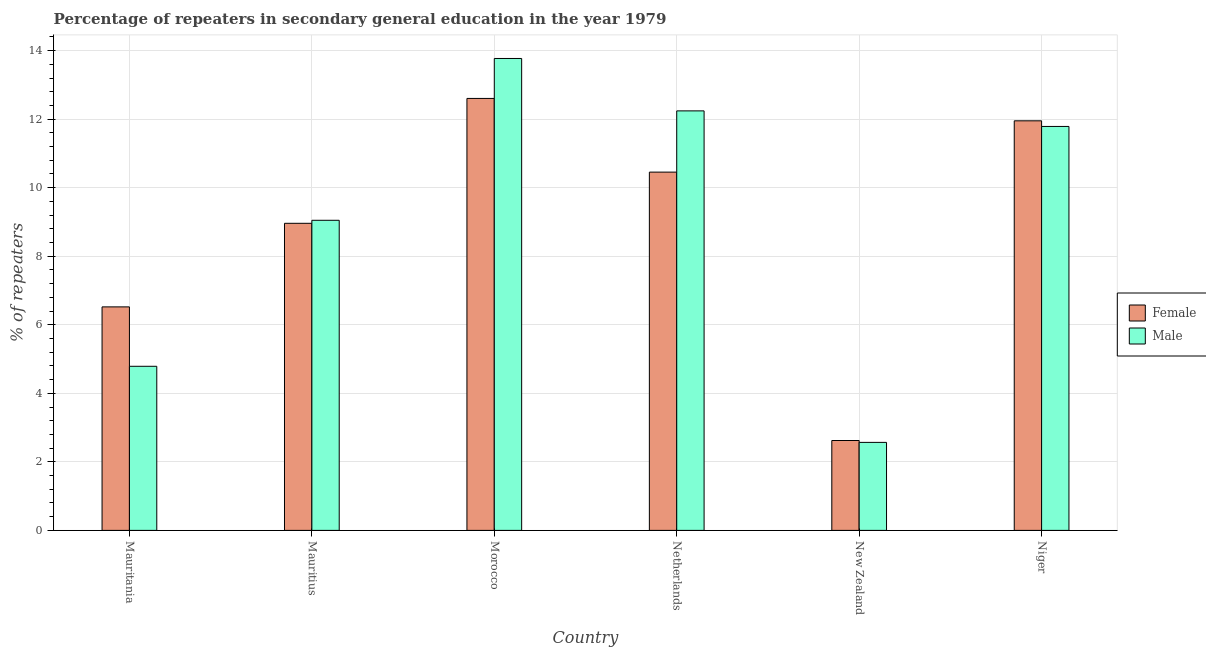How many different coloured bars are there?
Make the answer very short. 2. How many groups of bars are there?
Make the answer very short. 6. Are the number of bars on each tick of the X-axis equal?
Your response must be concise. Yes. How many bars are there on the 3rd tick from the left?
Your answer should be very brief. 2. What is the label of the 2nd group of bars from the left?
Provide a short and direct response. Mauritius. In how many cases, is the number of bars for a given country not equal to the number of legend labels?
Offer a very short reply. 0. What is the percentage of female repeaters in Mauritania?
Provide a succinct answer. 6.52. Across all countries, what is the maximum percentage of female repeaters?
Offer a very short reply. 12.6. Across all countries, what is the minimum percentage of male repeaters?
Offer a terse response. 2.57. In which country was the percentage of female repeaters maximum?
Give a very brief answer. Morocco. In which country was the percentage of female repeaters minimum?
Make the answer very short. New Zealand. What is the total percentage of male repeaters in the graph?
Your answer should be very brief. 54.2. What is the difference between the percentage of male repeaters in Mauritius and that in New Zealand?
Provide a short and direct response. 6.48. What is the difference between the percentage of female repeaters in Niger and the percentage of male repeaters in Mauritius?
Give a very brief answer. 2.9. What is the average percentage of female repeaters per country?
Give a very brief answer. 8.85. What is the difference between the percentage of male repeaters and percentage of female repeaters in Mauritius?
Your answer should be very brief. 0.09. In how many countries, is the percentage of male repeaters greater than 10 %?
Offer a very short reply. 3. What is the ratio of the percentage of female repeaters in Mauritania to that in Netherlands?
Offer a very short reply. 0.62. Is the difference between the percentage of female repeaters in Netherlands and New Zealand greater than the difference between the percentage of male repeaters in Netherlands and New Zealand?
Your answer should be very brief. No. What is the difference between the highest and the second highest percentage of male repeaters?
Your answer should be very brief. 1.53. What is the difference between the highest and the lowest percentage of male repeaters?
Ensure brevity in your answer.  11.2. In how many countries, is the percentage of male repeaters greater than the average percentage of male repeaters taken over all countries?
Give a very brief answer. 4. Is the sum of the percentage of female repeaters in Netherlands and Niger greater than the maximum percentage of male repeaters across all countries?
Your response must be concise. Yes. How many countries are there in the graph?
Provide a succinct answer. 6. Does the graph contain any zero values?
Offer a terse response. No. Does the graph contain grids?
Make the answer very short. Yes. Where does the legend appear in the graph?
Provide a short and direct response. Center right. What is the title of the graph?
Provide a short and direct response. Percentage of repeaters in secondary general education in the year 1979. What is the label or title of the X-axis?
Keep it short and to the point. Country. What is the label or title of the Y-axis?
Your response must be concise. % of repeaters. What is the % of repeaters of Female in Mauritania?
Give a very brief answer. 6.52. What is the % of repeaters of Male in Mauritania?
Make the answer very short. 4.79. What is the % of repeaters in Female in Mauritius?
Provide a short and direct response. 8.96. What is the % of repeaters of Male in Mauritius?
Give a very brief answer. 9.05. What is the % of repeaters in Female in Morocco?
Your response must be concise. 12.6. What is the % of repeaters of Male in Morocco?
Provide a succinct answer. 13.77. What is the % of repeaters in Female in Netherlands?
Keep it short and to the point. 10.45. What is the % of repeaters in Male in Netherlands?
Ensure brevity in your answer.  12.24. What is the % of repeaters of Female in New Zealand?
Offer a terse response. 2.62. What is the % of repeaters in Male in New Zealand?
Your answer should be compact. 2.57. What is the % of repeaters in Female in Niger?
Offer a very short reply. 11.95. What is the % of repeaters in Male in Niger?
Provide a succinct answer. 11.79. Across all countries, what is the maximum % of repeaters in Female?
Provide a short and direct response. 12.6. Across all countries, what is the maximum % of repeaters in Male?
Your answer should be very brief. 13.77. Across all countries, what is the minimum % of repeaters in Female?
Give a very brief answer. 2.62. Across all countries, what is the minimum % of repeaters of Male?
Your answer should be compact. 2.57. What is the total % of repeaters of Female in the graph?
Keep it short and to the point. 53.11. What is the total % of repeaters in Male in the graph?
Your answer should be compact. 54.2. What is the difference between the % of repeaters in Female in Mauritania and that in Mauritius?
Your response must be concise. -2.44. What is the difference between the % of repeaters of Male in Mauritania and that in Mauritius?
Provide a short and direct response. -4.26. What is the difference between the % of repeaters in Female in Mauritania and that in Morocco?
Ensure brevity in your answer.  -6.08. What is the difference between the % of repeaters of Male in Mauritania and that in Morocco?
Keep it short and to the point. -8.98. What is the difference between the % of repeaters of Female in Mauritania and that in Netherlands?
Your response must be concise. -3.93. What is the difference between the % of repeaters of Male in Mauritania and that in Netherlands?
Ensure brevity in your answer.  -7.45. What is the difference between the % of repeaters of Female in Mauritania and that in New Zealand?
Offer a very short reply. 3.9. What is the difference between the % of repeaters of Male in Mauritania and that in New Zealand?
Give a very brief answer. 2.22. What is the difference between the % of repeaters in Female in Mauritania and that in Niger?
Give a very brief answer. -5.43. What is the difference between the % of repeaters in Male in Mauritania and that in Niger?
Provide a short and direct response. -7. What is the difference between the % of repeaters of Female in Mauritius and that in Morocco?
Offer a very short reply. -3.64. What is the difference between the % of repeaters of Male in Mauritius and that in Morocco?
Your answer should be compact. -4.72. What is the difference between the % of repeaters of Female in Mauritius and that in Netherlands?
Provide a short and direct response. -1.49. What is the difference between the % of repeaters of Male in Mauritius and that in Netherlands?
Provide a succinct answer. -3.19. What is the difference between the % of repeaters of Female in Mauritius and that in New Zealand?
Offer a terse response. 6.34. What is the difference between the % of repeaters in Male in Mauritius and that in New Zealand?
Ensure brevity in your answer.  6.48. What is the difference between the % of repeaters of Female in Mauritius and that in Niger?
Give a very brief answer. -2.99. What is the difference between the % of repeaters in Male in Mauritius and that in Niger?
Ensure brevity in your answer.  -2.74. What is the difference between the % of repeaters in Female in Morocco and that in Netherlands?
Offer a terse response. 2.15. What is the difference between the % of repeaters in Male in Morocco and that in Netherlands?
Offer a terse response. 1.53. What is the difference between the % of repeaters of Female in Morocco and that in New Zealand?
Your response must be concise. 9.98. What is the difference between the % of repeaters in Male in Morocco and that in New Zealand?
Your response must be concise. 11.2. What is the difference between the % of repeaters of Female in Morocco and that in Niger?
Make the answer very short. 0.65. What is the difference between the % of repeaters in Male in Morocco and that in Niger?
Offer a very short reply. 1.98. What is the difference between the % of repeaters in Female in Netherlands and that in New Zealand?
Offer a terse response. 7.83. What is the difference between the % of repeaters of Male in Netherlands and that in New Zealand?
Offer a very short reply. 9.67. What is the difference between the % of repeaters in Female in Netherlands and that in Niger?
Give a very brief answer. -1.5. What is the difference between the % of repeaters in Male in Netherlands and that in Niger?
Offer a very short reply. 0.45. What is the difference between the % of repeaters in Female in New Zealand and that in Niger?
Give a very brief answer. -9.33. What is the difference between the % of repeaters in Male in New Zealand and that in Niger?
Give a very brief answer. -9.22. What is the difference between the % of repeaters of Female in Mauritania and the % of repeaters of Male in Mauritius?
Give a very brief answer. -2.53. What is the difference between the % of repeaters of Female in Mauritania and the % of repeaters of Male in Morocco?
Your response must be concise. -7.25. What is the difference between the % of repeaters in Female in Mauritania and the % of repeaters in Male in Netherlands?
Provide a succinct answer. -5.72. What is the difference between the % of repeaters in Female in Mauritania and the % of repeaters in Male in New Zealand?
Offer a terse response. 3.95. What is the difference between the % of repeaters of Female in Mauritania and the % of repeaters of Male in Niger?
Make the answer very short. -5.26. What is the difference between the % of repeaters of Female in Mauritius and the % of repeaters of Male in Morocco?
Provide a short and direct response. -4.81. What is the difference between the % of repeaters in Female in Mauritius and the % of repeaters in Male in Netherlands?
Offer a very short reply. -3.28. What is the difference between the % of repeaters of Female in Mauritius and the % of repeaters of Male in New Zealand?
Keep it short and to the point. 6.39. What is the difference between the % of repeaters in Female in Mauritius and the % of repeaters in Male in Niger?
Provide a succinct answer. -2.83. What is the difference between the % of repeaters in Female in Morocco and the % of repeaters in Male in Netherlands?
Provide a succinct answer. 0.36. What is the difference between the % of repeaters of Female in Morocco and the % of repeaters of Male in New Zealand?
Offer a terse response. 10.04. What is the difference between the % of repeaters of Female in Morocco and the % of repeaters of Male in Niger?
Make the answer very short. 0.82. What is the difference between the % of repeaters of Female in Netherlands and the % of repeaters of Male in New Zealand?
Offer a terse response. 7.89. What is the difference between the % of repeaters in Female in Netherlands and the % of repeaters in Male in Niger?
Give a very brief answer. -1.33. What is the difference between the % of repeaters of Female in New Zealand and the % of repeaters of Male in Niger?
Give a very brief answer. -9.16. What is the average % of repeaters of Female per country?
Give a very brief answer. 8.85. What is the average % of repeaters in Male per country?
Provide a succinct answer. 9.03. What is the difference between the % of repeaters in Female and % of repeaters in Male in Mauritania?
Keep it short and to the point. 1.73. What is the difference between the % of repeaters of Female and % of repeaters of Male in Mauritius?
Keep it short and to the point. -0.09. What is the difference between the % of repeaters of Female and % of repeaters of Male in Morocco?
Provide a short and direct response. -1.17. What is the difference between the % of repeaters in Female and % of repeaters in Male in Netherlands?
Make the answer very short. -1.79. What is the difference between the % of repeaters in Female and % of repeaters in Male in New Zealand?
Your answer should be compact. 0.05. What is the difference between the % of repeaters in Female and % of repeaters in Male in Niger?
Ensure brevity in your answer.  0.16. What is the ratio of the % of repeaters of Female in Mauritania to that in Mauritius?
Offer a terse response. 0.73. What is the ratio of the % of repeaters in Male in Mauritania to that in Mauritius?
Provide a succinct answer. 0.53. What is the ratio of the % of repeaters of Female in Mauritania to that in Morocco?
Keep it short and to the point. 0.52. What is the ratio of the % of repeaters of Male in Mauritania to that in Morocco?
Keep it short and to the point. 0.35. What is the ratio of the % of repeaters in Female in Mauritania to that in Netherlands?
Offer a very short reply. 0.62. What is the ratio of the % of repeaters of Male in Mauritania to that in Netherlands?
Give a very brief answer. 0.39. What is the ratio of the % of repeaters in Female in Mauritania to that in New Zealand?
Keep it short and to the point. 2.49. What is the ratio of the % of repeaters in Male in Mauritania to that in New Zealand?
Offer a terse response. 1.86. What is the ratio of the % of repeaters in Female in Mauritania to that in Niger?
Ensure brevity in your answer.  0.55. What is the ratio of the % of repeaters in Male in Mauritania to that in Niger?
Your response must be concise. 0.41. What is the ratio of the % of repeaters in Female in Mauritius to that in Morocco?
Your response must be concise. 0.71. What is the ratio of the % of repeaters of Male in Mauritius to that in Morocco?
Offer a very short reply. 0.66. What is the ratio of the % of repeaters of Female in Mauritius to that in Netherlands?
Your answer should be compact. 0.86. What is the ratio of the % of repeaters in Male in Mauritius to that in Netherlands?
Give a very brief answer. 0.74. What is the ratio of the % of repeaters of Female in Mauritius to that in New Zealand?
Give a very brief answer. 3.42. What is the ratio of the % of repeaters in Male in Mauritius to that in New Zealand?
Offer a very short reply. 3.52. What is the ratio of the % of repeaters of Female in Mauritius to that in Niger?
Your answer should be very brief. 0.75. What is the ratio of the % of repeaters of Male in Mauritius to that in Niger?
Your response must be concise. 0.77. What is the ratio of the % of repeaters of Female in Morocco to that in Netherlands?
Provide a succinct answer. 1.21. What is the ratio of the % of repeaters of Male in Morocco to that in Netherlands?
Give a very brief answer. 1.12. What is the ratio of the % of repeaters in Female in Morocco to that in New Zealand?
Give a very brief answer. 4.81. What is the ratio of the % of repeaters of Male in Morocco to that in New Zealand?
Keep it short and to the point. 5.36. What is the ratio of the % of repeaters in Female in Morocco to that in Niger?
Your answer should be very brief. 1.05. What is the ratio of the % of repeaters in Male in Morocco to that in Niger?
Offer a terse response. 1.17. What is the ratio of the % of repeaters in Female in Netherlands to that in New Zealand?
Your response must be concise. 3.99. What is the ratio of the % of repeaters in Male in Netherlands to that in New Zealand?
Ensure brevity in your answer.  4.77. What is the ratio of the % of repeaters in Female in Netherlands to that in Niger?
Your answer should be very brief. 0.87. What is the ratio of the % of repeaters in Female in New Zealand to that in Niger?
Offer a very short reply. 0.22. What is the ratio of the % of repeaters in Male in New Zealand to that in Niger?
Your answer should be compact. 0.22. What is the difference between the highest and the second highest % of repeaters of Female?
Ensure brevity in your answer.  0.65. What is the difference between the highest and the second highest % of repeaters in Male?
Provide a short and direct response. 1.53. What is the difference between the highest and the lowest % of repeaters in Female?
Provide a succinct answer. 9.98. What is the difference between the highest and the lowest % of repeaters of Male?
Offer a terse response. 11.2. 